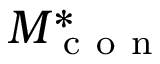Convert formula to latex. <formula><loc_0><loc_0><loc_500><loc_500>M _ { c o n } ^ { * }</formula> 